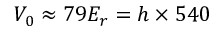Convert formula to latex. <formula><loc_0><loc_0><loc_500><loc_500>V _ { 0 } \approx 7 9 E _ { r } = h \times 5 4 0</formula> 